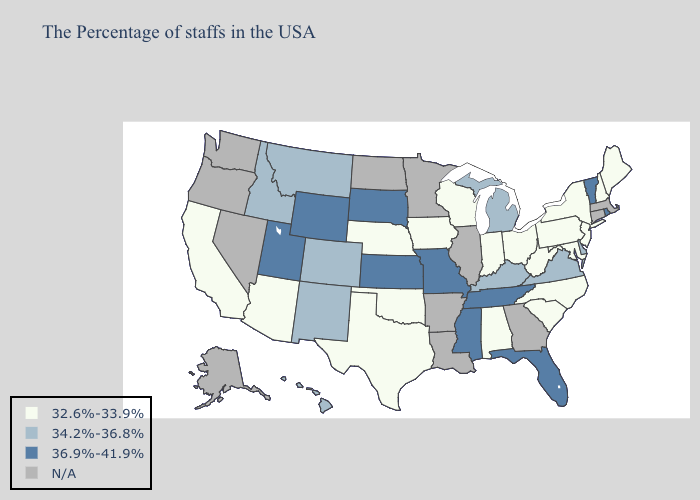What is the lowest value in states that border Nebraska?
Quick response, please. 32.6%-33.9%. What is the highest value in the Northeast ?
Answer briefly. 36.9%-41.9%. Among the states that border Wisconsin , does Iowa have the highest value?
Give a very brief answer. No. What is the value of North Carolina?
Short answer required. 32.6%-33.9%. Among the states that border Texas , does New Mexico have the highest value?
Give a very brief answer. Yes. Name the states that have a value in the range 32.6%-33.9%?
Concise answer only. Maine, New Hampshire, New York, New Jersey, Maryland, Pennsylvania, North Carolina, South Carolina, West Virginia, Ohio, Indiana, Alabama, Wisconsin, Iowa, Nebraska, Oklahoma, Texas, Arizona, California. Does the first symbol in the legend represent the smallest category?
Keep it brief. Yes. Name the states that have a value in the range 36.9%-41.9%?
Quick response, please. Rhode Island, Vermont, Florida, Tennessee, Mississippi, Missouri, Kansas, South Dakota, Wyoming, Utah. Among the states that border Louisiana , does Mississippi have the highest value?
Concise answer only. Yes. Does the map have missing data?
Give a very brief answer. Yes. What is the value of California?
Quick response, please. 32.6%-33.9%. Name the states that have a value in the range N/A?
Answer briefly. Massachusetts, Connecticut, Georgia, Illinois, Louisiana, Arkansas, Minnesota, North Dakota, Nevada, Washington, Oregon, Alaska. Does Tennessee have the highest value in the South?
Concise answer only. Yes. Name the states that have a value in the range 34.2%-36.8%?
Give a very brief answer. Delaware, Virginia, Michigan, Kentucky, Colorado, New Mexico, Montana, Idaho, Hawaii. What is the value of Florida?
Give a very brief answer. 36.9%-41.9%. 